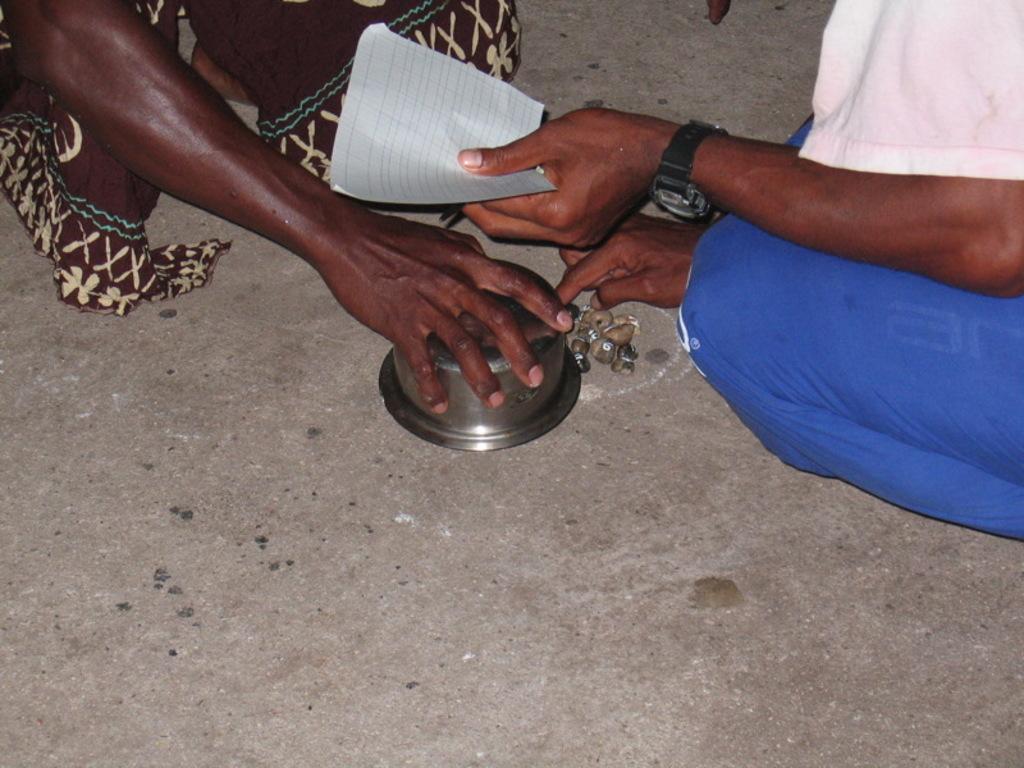Could you give a brief overview of what you see in this image? In this image I can see two persons and the person at right is wearing white and blue color dress and I can see the bowl and I can also see the paper in white color. 